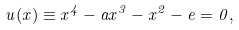<formula> <loc_0><loc_0><loc_500><loc_500>u ( x ) \equiv x ^ { 4 } - a x ^ { 3 } - x ^ { 2 } - e = 0 ,</formula> 